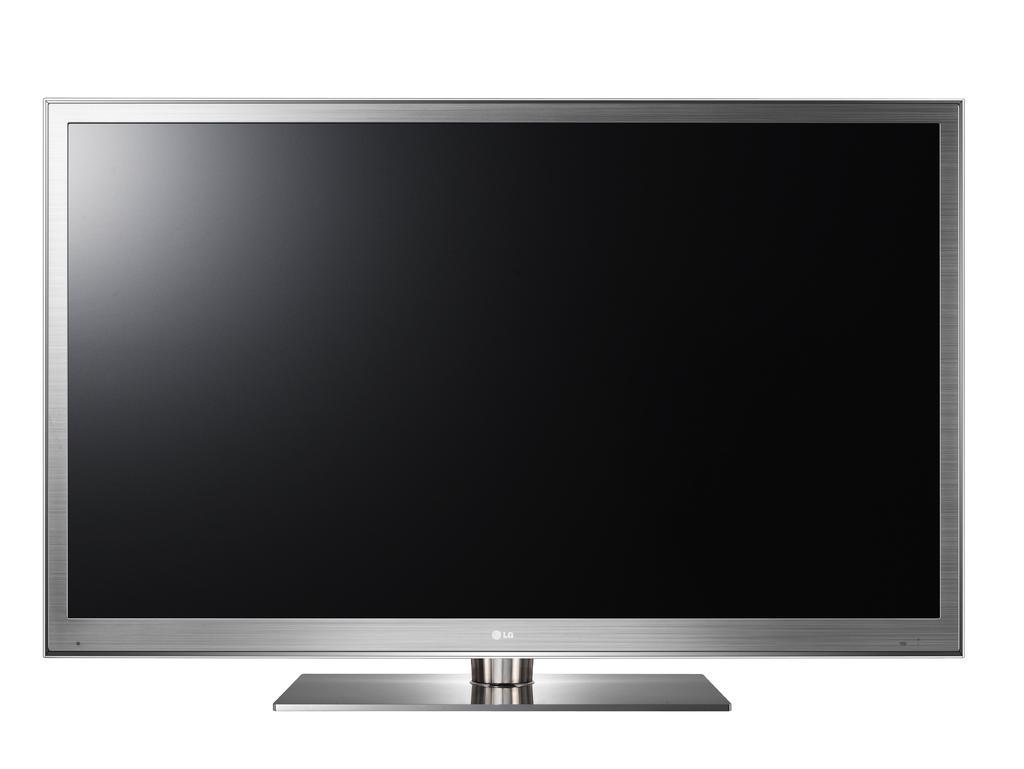Please provide a concise description of this image. Here in this picture we can see a television present over there. 